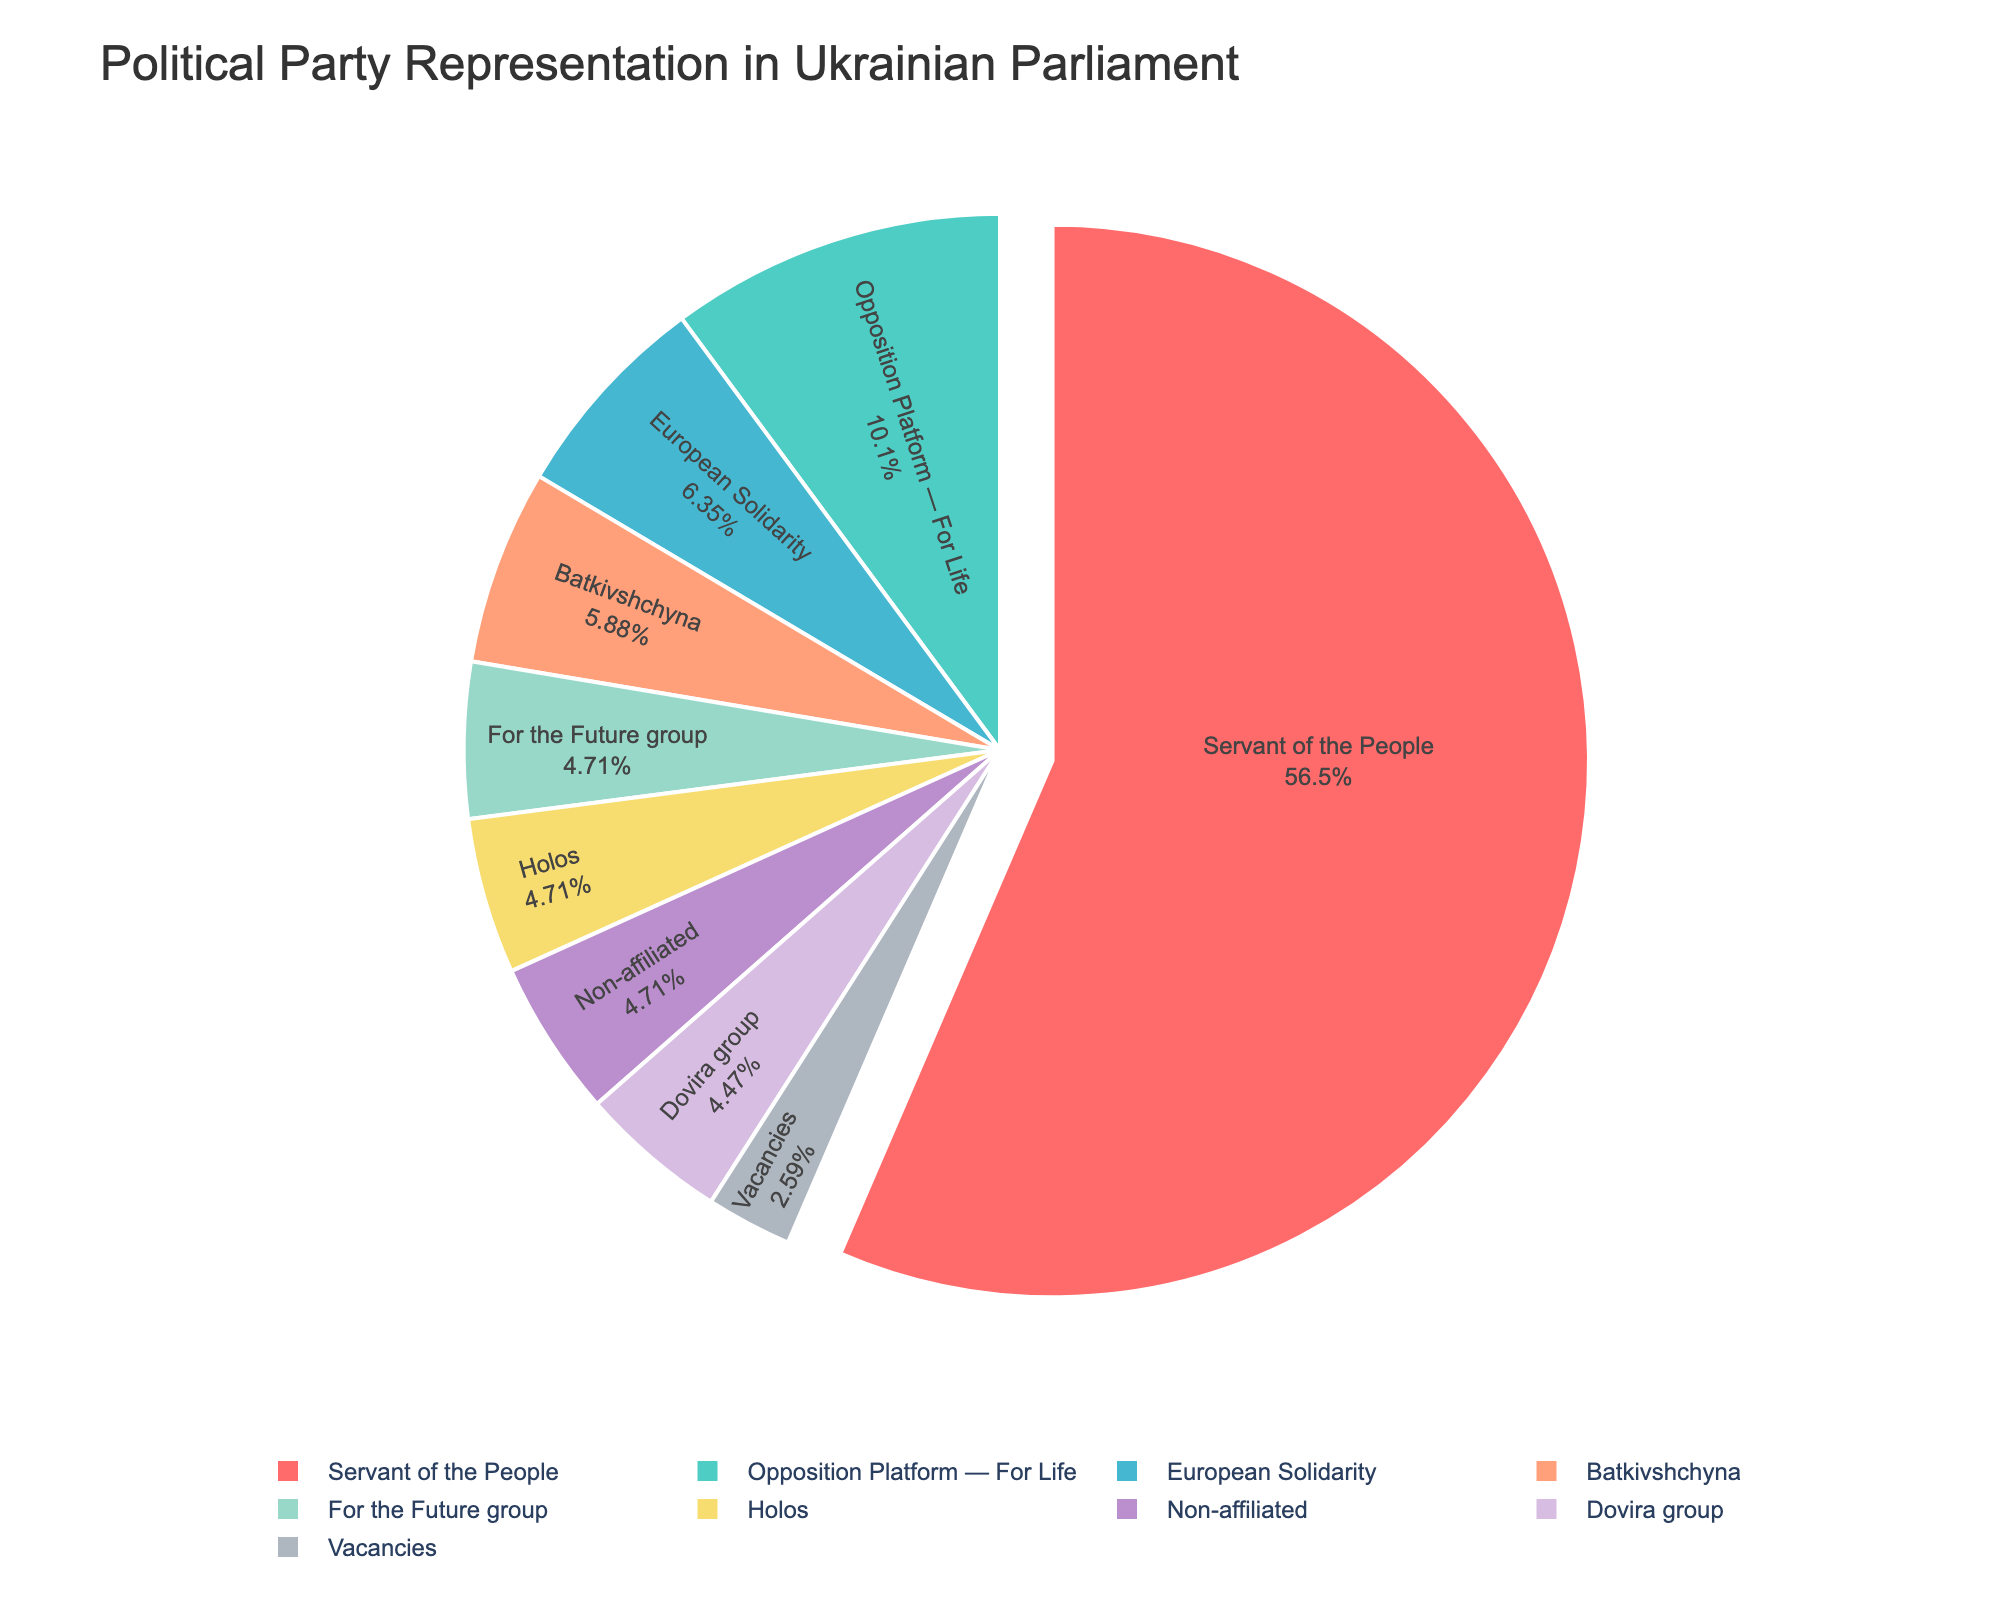What's the largest represented political party in the Ukrainian parliament? The pie chart shows the size of each party's representation. The "Servant of the People" party has the largest segment.
Answer: Servant of the People How many seats do opposition parties collectively hold ('Opposition Platform — For Life', 'European Solidarity', 'Batkivshchyna')? Sum the seats of the opposition parties: Opposition Platform — For Life (43) + European Solidarity (27) + Batkivshchyna (25) = 95 seats.
Answer: 95 Which two parties have an equal number of seats and how many seats do they each hold? The chart shows that both 'Holos' and 'For the Future group' each have the same segment size. They both hold 20 seats.
Answer: 'Holos' and 'For the Future group', 20 seats each What's the total percentage of seats represented by non-affiliated members and vacancies? Calculate the percentage of non-affiliated seats (20) and vacancies (11) relative to the total number of seats (425): (20 + 11) / 425 * 100 = 7.29%.
Answer: 7.29% What is the party with the least representation and how many seats do they hold? The smallest segment in the pie chart is for 'Vacancies', which holds 11 seats.
Answer: Vacancies, 11 seats How much more representation does 'Servant of the People' have compared to 'Opposition Platform — For Life'? The difference in the seats is calculated as 240 (Servant of the People) - 43 (Opposition Platform — For Life) = 197 seats.
Answer: 197 more seats Is there any group representation that exceeds 50% of the total seats? The 'Servant of the People' segment visually dominates the chart and represents more than half of the total seats (240 / 425 * 100 = 56.47%).
Answer: Yes, 'Servant of the People' What is the combined percentage representation of 'For the Future group', 'Holos', and 'Dovira group'? Calculate the combined percentage: ((20 + 20 + 19) / 425) * 100 = 13.65%.
Answer: 13.65% 